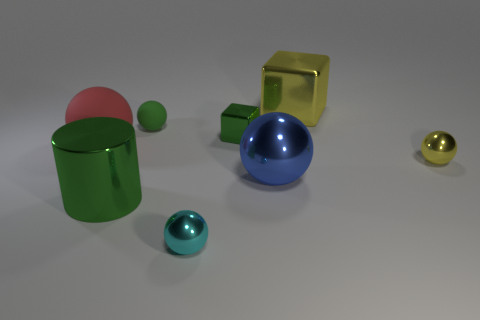What is the color of the large ball that is made of the same material as the green cube?
Your answer should be very brief. Blue. Does the small metal thing that is in front of the cylinder have the same shape as the blue shiny object?
Your answer should be compact. Yes. What number of objects are either green metallic objects that are in front of the tiny yellow sphere or metal spheres in front of the tiny yellow object?
Offer a very short reply. 3. There is another large metallic object that is the same shape as the cyan thing; what is its color?
Ensure brevity in your answer.  Blue. Is there anything else that is the same shape as the cyan metallic thing?
Your answer should be compact. Yes. Does the blue shiny thing have the same shape as the yellow thing that is in front of the big matte ball?
Ensure brevity in your answer.  Yes. What is the material of the tiny cyan ball?
Offer a very short reply. Metal. What is the size of the green matte thing that is the same shape as the blue shiny object?
Your answer should be very brief. Small. How many other objects are there of the same material as the big yellow cube?
Provide a succinct answer. 5. Do the big blue object and the cube that is in front of the large yellow metal block have the same material?
Make the answer very short. Yes. 